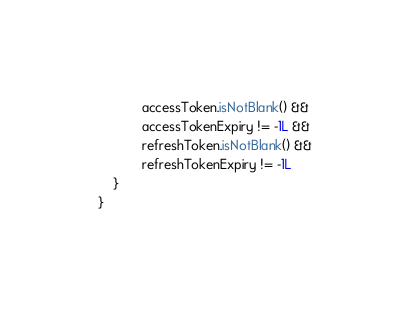Convert code to text. <code><loc_0><loc_0><loc_500><loc_500><_Kotlin_>            accessToken.isNotBlank() &&
            accessTokenExpiry != -1L &&
            refreshToken.isNotBlank() &&
            refreshTokenExpiry != -1L
    }
}</code> 